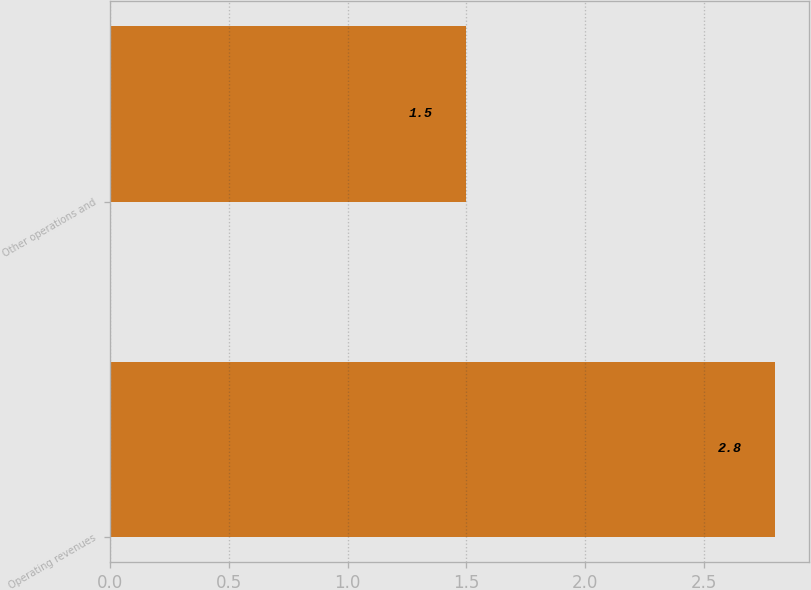<chart> <loc_0><loc_0><loc_500><loc_500><bar_chart><fcel>Operating revenues<fcel>Other operations and<nl><fcel>2.8<fcel>1.5<nl></chart> 